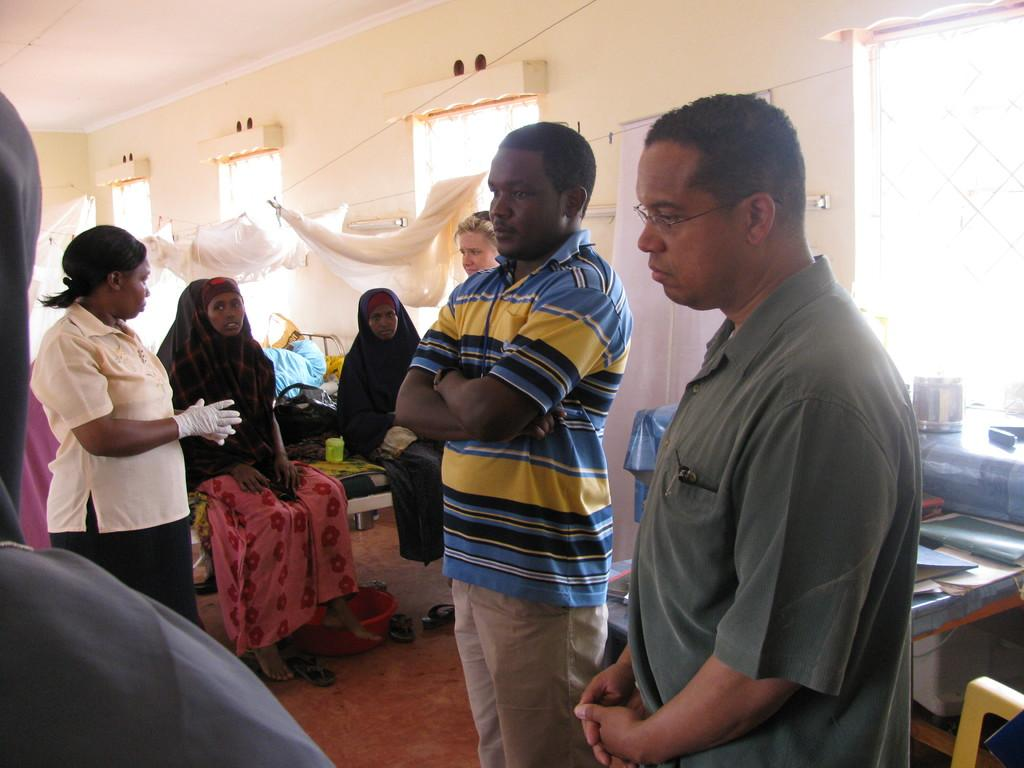What types of individuals are present in the image? There are people in the image, including men and women. Can you describe the location of the table in the image? The table is on the right side of the image. What can be seen in the background of the image? There are windows and curtains in the background of the image. What type of ship can be seen sailing in the background of the image? There is no ship visible in the background of the image; it only features windows and curtains. Is there any blood visible on the people in the image? There is no indication of blood or any injuries on the people in the image. 